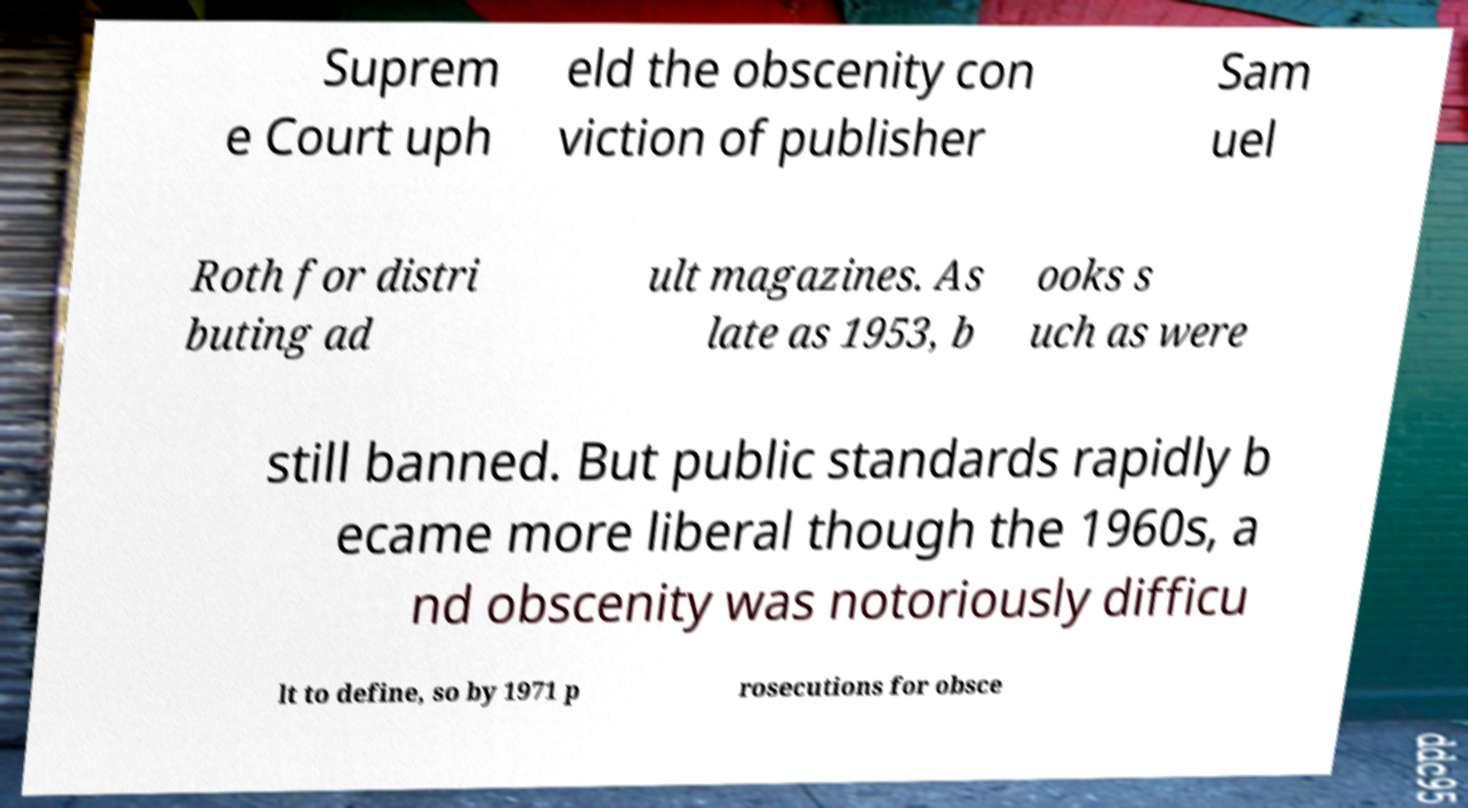What messages or text are displayed in this image? I need them in a readable, typed format. Suprem e Court uph eld the obscenity con viction of publisher Sam uel Roth for distri buting ad ult magazines. As late as 1953, b ooks s uch as were still banned. But public standards rapidly b ecame more liberal though the 1960s, a nd obscenity was notoriously difficu lt to define, so by 1971 p rosecutions for obsce 